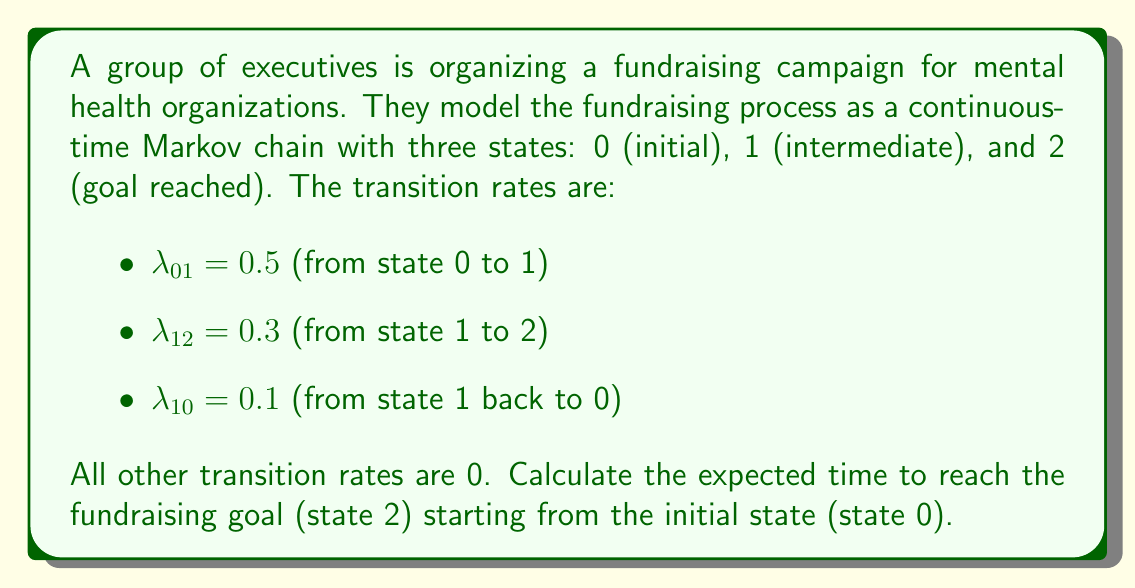Can you answer this question? To solve this problem, we'll use the first step analysis method for continuous-time Markov chains.

Let $T_i$ be the expected time to reach state 2 starting from state $i$. We need to find $T_0$.

Step 1: Set up equations for $T_0$ and $T_1$:

$$T_0 = \frac{1}{\lambda_{01}} + T_1$$
$$T_1 = \frac{1}{\lambda_{12} + \lambda_{10}} + \frac{\lambda_{10}}{\lambda_{12} + \lambda_{10}}T_0 + \frac{\lambda_{12}}{\lambda_{12} + \lambda_{10}} \cdot 0$$

Step 2: Simplify the equation for $T_1$:

$$T_1 = \frac{1}{0.3 + 0.1} + \frac{0.1}{0.4}T_0 = 2.5 + 0.25T_0$$

Step 3: Substitute $T_1$ into the equation for $T_0$:

$$T_0 = \frac{1}{0.5} + (2.5 + 0.25T_0)$$
$$T_0 = 2 + 2.5 + 0.25T_0$$
$$0.75T_0 = 4.5$$

Step 4: Solve for $T_0$:

$$T_0 = \frac{4.5}{0.75} = 6$$

Therefore, the expected time to reach the fundraising goal (state 2) starting from the initial state (state 0) is 6 time units.
Answer: 6 time units 